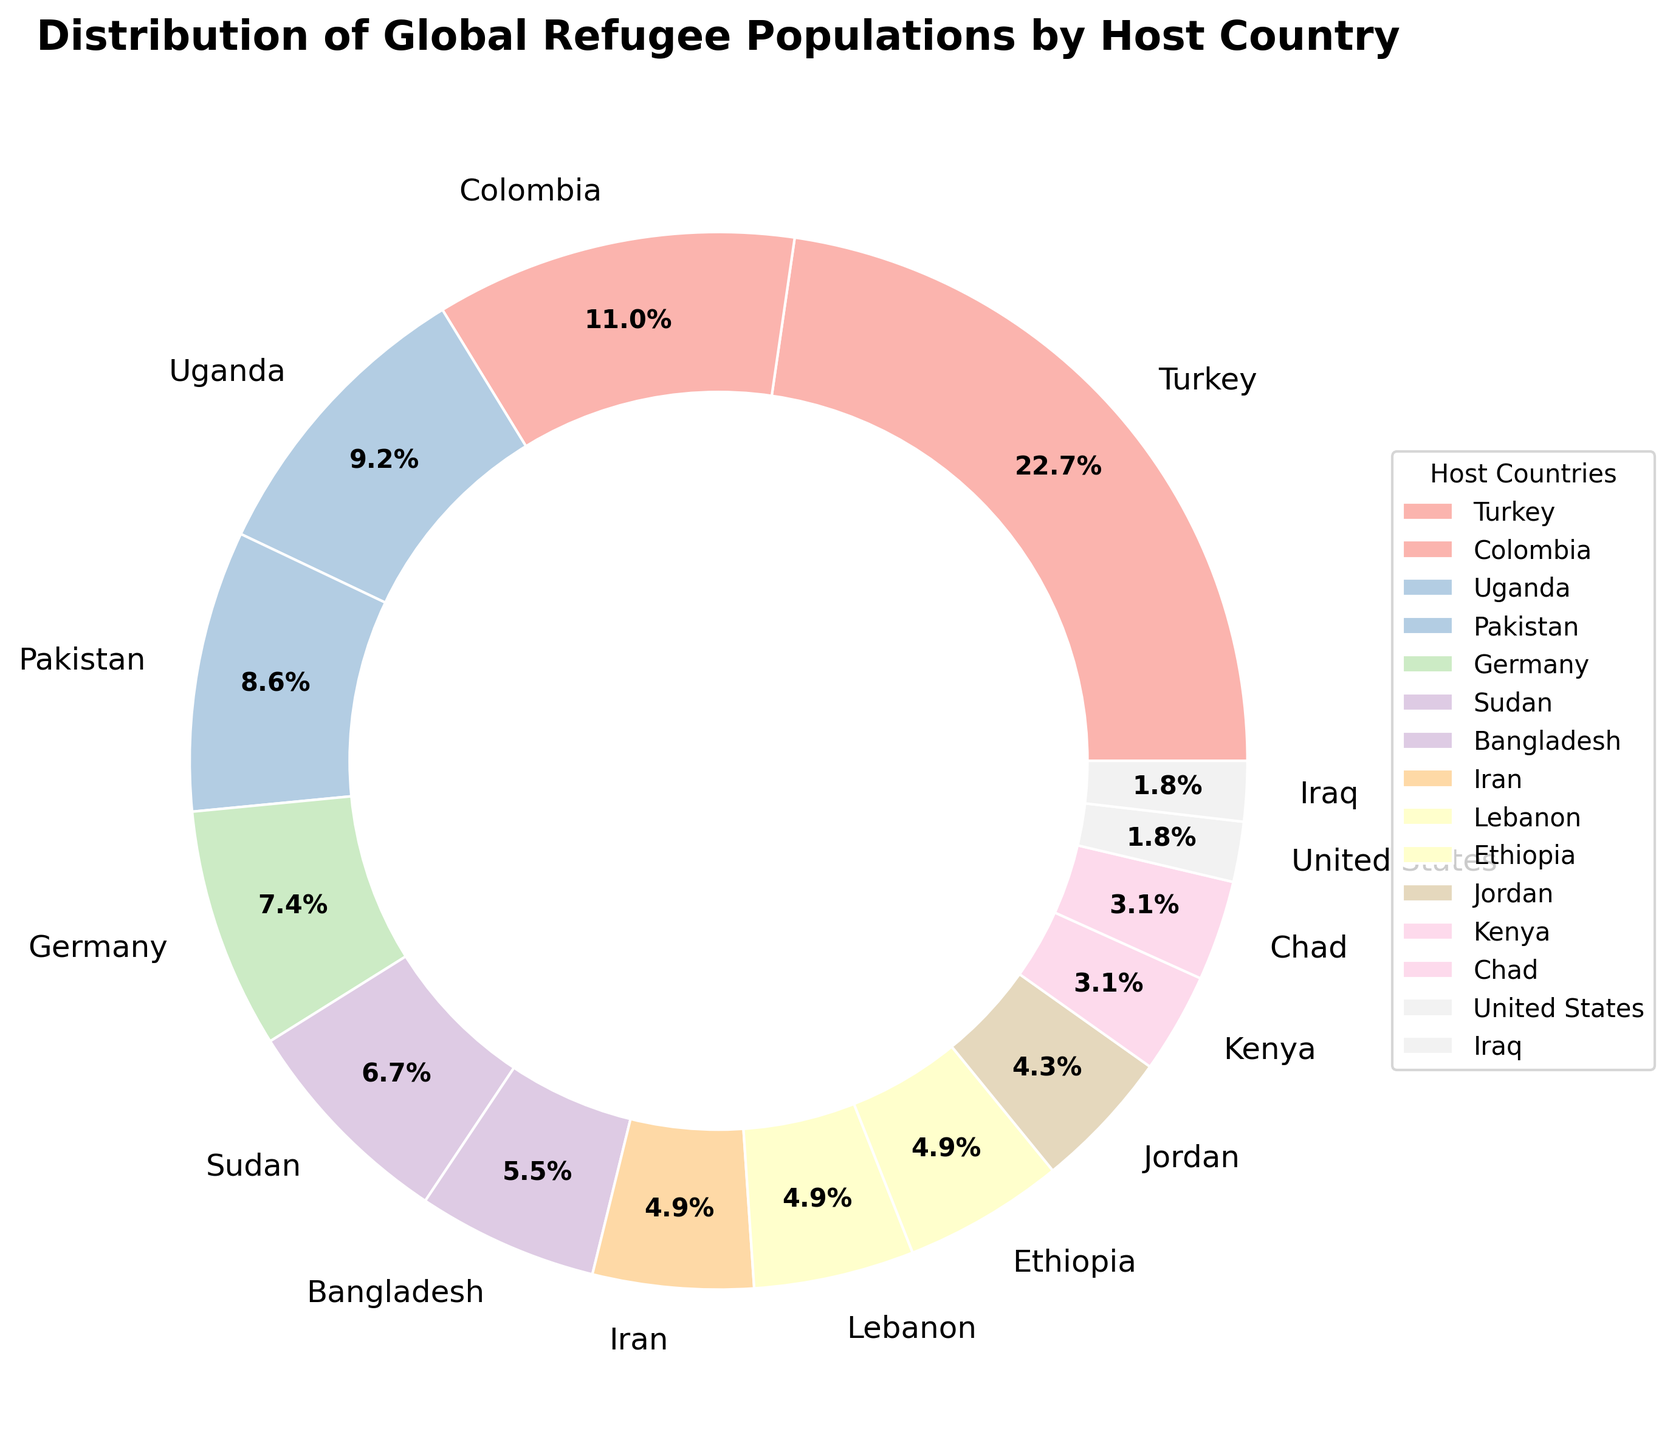What percentage of the global refugee population is hosted by Turkey? The pie chart shows that Turkey hosts 3.7 million refugees, which translates to 21.9% of the global refugee population. Therefore, the percentage can be directly read from the chart.
Answer: 21.9% Compare the refugee populations hosted by Germany and Uganda. Which country hosts more and by how much? Germany hosts 1.2 million refugees, while Uganda hosts 1.5 million. By subtracting the populations, (1.5 - 1.2) we see that Uganda hosts 0.3 million more refugees than Germany.
Answer: Uganda by 0.3 million What is the combined percentage of refugees hosted by Colombia and Pakistan? According to the chart, Colombia hosts 1.8 million refugees (10.7%) and Pakistan hosts 1.4 million refugees (8.3%). The combined percentage is the sum of these two percentages: 10.7% + 8.3% = 19.0%.
Answer: 19.0% Which countries host exactly 0.8 million refugees? The pie chart indicates that Iran, Lebanon, and Ethiopia each host 0.8 million refugees.
Answer: Iran, Lebanon, Ethiopia Which country, among the ones listed, hosts the smallest percentage of the global refugee population? The United States and Iraq each host 0.3 million refugees. Since no country listed hosts fewer than 0.3 million refugees, they both share the smallest percentage.
Answer: United States, Iraq What is the difference in the percentage of refugees hosted by Turkey and Germany? Turkey hosts 21.9% and Germany hosts 7.1% of the global refugee population. By calculating the difference (21.9 - 7.1), we find the answer is 14.8%.
Answer: 14.8% Determine the total refugee percentage accounted for by Sudan, Bangladesh, Iran, and Lebanon together. Sudan hosts 6.5%, Bangladesh 5.4%, Iran 4.7%, and Lebanon 4.7%. Summing these percentages gives: 6.5 + 5.4 + 4.7 + 4.7 = 21.3%.
Answer: 21.3% Identify the countries that host between 0.5 and 1.0 million refugees. The countries that fall in this range on the pie chart are Bangladesh (0.9 million), Iran (0.8 million), Lebanon (0.8 million), Ethiopia (0.8 million), and Jordan (0.7 million).
Answer: Bangladesh, Iran, Lebanon, Ethiopia, Jordan 